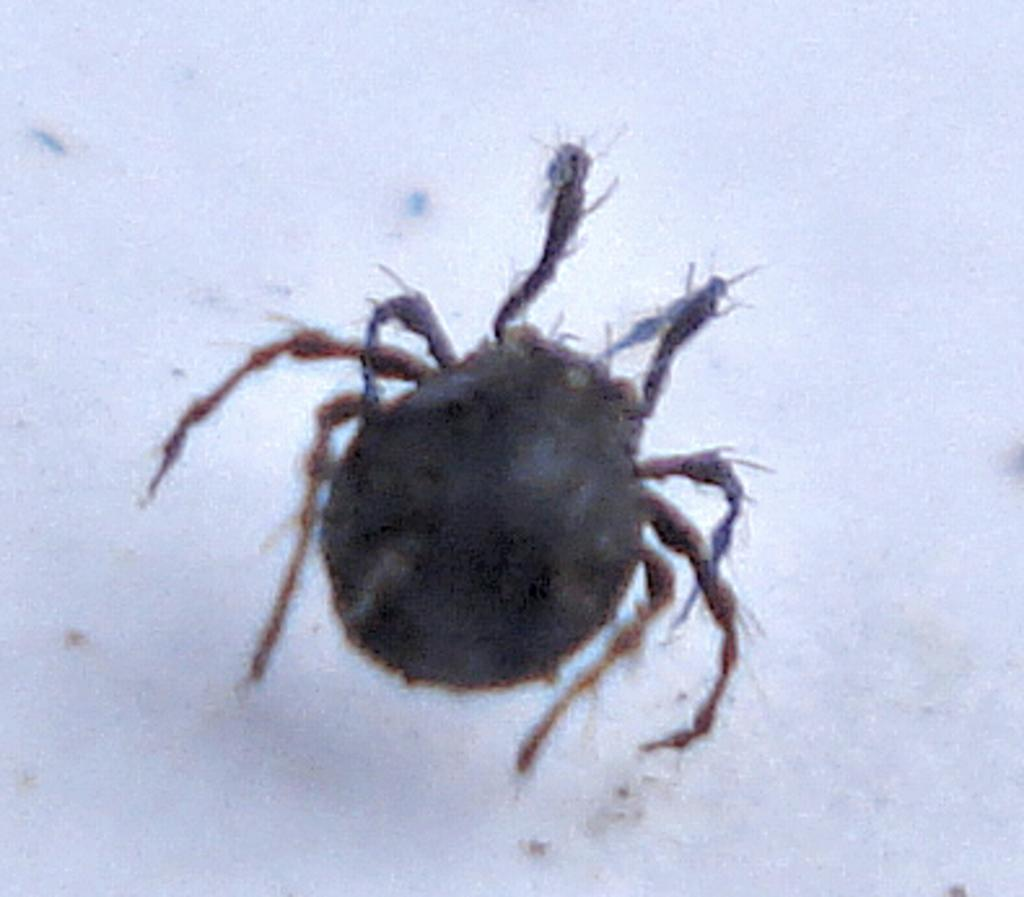What type of creature can be seen in the image? There is an insect in the image. What type of precipitation is falling in the image? There is no precipitation present in the image; it only features an insect. How does the insect contribute to the health of the ecosystem in the image? The image does not provide enough information to determine the insect's role in the ecosystem or its impact on health. 